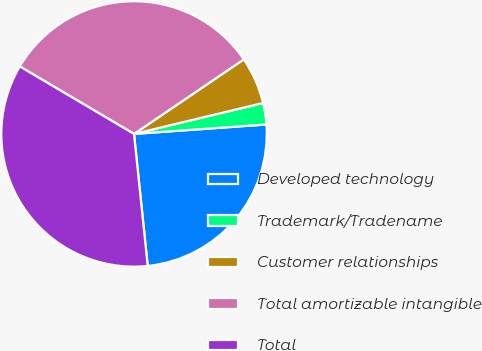<chart> <loc_0><loc_0><loc_500><loc_500><pie_chart><fcel>Developed technology<fcel>Trademark/Tradename<fcel>Customer relationships<fcel>Total amortizable intangible<fcel>Total<nl><fcel>24.49%<fcel>2.61%<fcel>5.75%<fcel>32.01%<fcel>35.14%<nl></chart> 